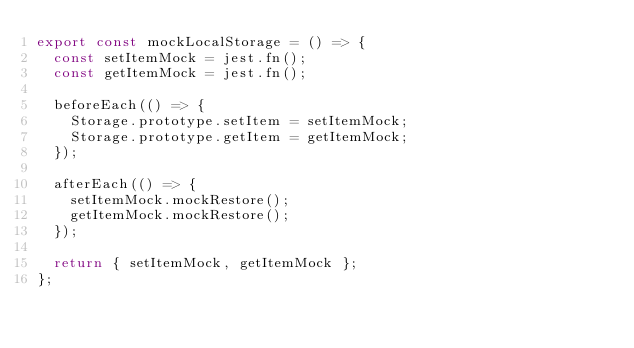<code> <loc_0><loc_0><loc_500><loc_500><_TypeScript_>export const mockLocalStorage = () => {
  const setItemMock = jest.fn();
  const getItemMock = jest.fn();

  beforeEach(() => {
    Storage.prototype.setItem = setItemMock;
    Storage.prototype.getItem = getItemMock;
  });

  afterEach(() => {
    setItemMock.mockRestore();
    getItemMock.mockRestore();
  });

  return { setItemMock, getItemMock };
};</code> 